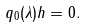Convert formula to latex. <formula><loc_0><loc_0><loc_500><loc_500>q _ { 0 } ( \lambda ) { h } = 0 .</formula> 